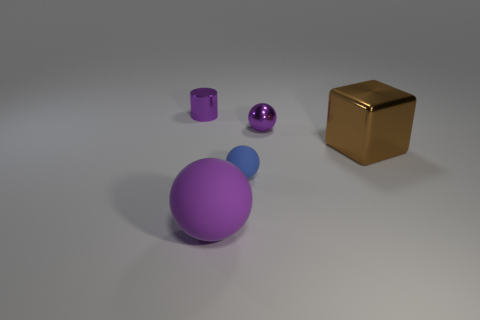The blue ball has what size?
Keep it short and to the point. Small. There is a rubber sphere to the left of the tiny rubber object; how big is it?
Your answer should be compact. Large. Does the shiny thing on the left side of the blue rubber sphere have the same size as the block?
Make the answer very short. No. Is there any other thing that has the same color as the big metal thing?
Provide a succinct answer. No. What is the shape of the large purple thing?
Provide a succinct answer. Sphere. What number of objects are both on the left side of the big purple sphere and in front of the tiny blue sphere?
Provide a succinct answer. 0. Do the small cylinder and the large cube have the same color?
Give a very brief answer. No. What material is the other purple thing that is the same shape as the large rubber object?
Offer a terse response. Metal. Is there any other thing that has the same material as the large purple object?
Offer a terse response. Yes. Is the number of matte objects that are behind the small matte sphere the same as the number of tiny metal balls to the left of the cylinder?
Offer a very short reply. Yes. 